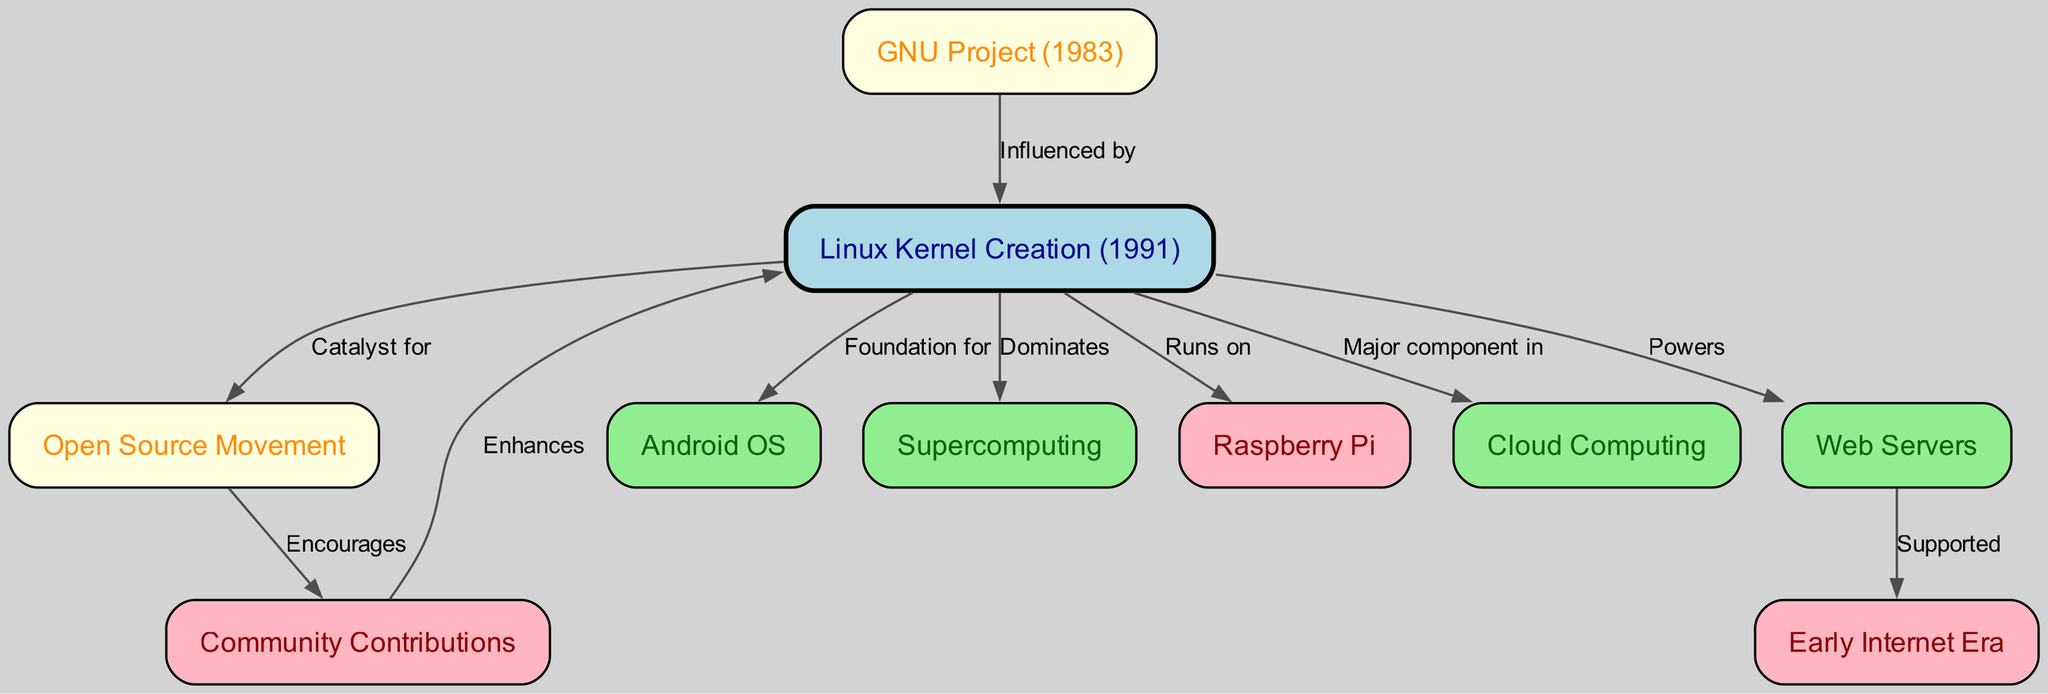What year was the Linux kernel created? The diagram indicates that the Linux kernel was created in 1991. This information can be found directly labeled in the node for "Linux Kernel Creation".
Answer: 1991 What influenced the creation of the Linux kernel? The diagram shows that the "GNU Project" influenced the "Linux Kernel Creation". The relationship is labeled as "Influenced by" in the edge connecting these two nodes.
Answer: GNU Project How many nodes are in the diagram? By counting the nodes listed in the diagram, we see there are 10 unique nodes. This total is determined by examining the nodes section of the data provided.
Answer: 10 What does the Linux kernel dominate in? The diagram states that the Linux kernel "Dominates" supercomputing, indicating its strong presence or leadership in that field, as marked by the directional edge from "Linux Kernel Creation" to "Supercomputing".
Answer: Supercomputing Which technology is the foundation for Android OS? According to the diagram, the "Linux Kernel Creation" serves as the "Foundation for" the "Android OS". This relationship is mapped in the edge pointing from the Linux kernel to the Android OS node.
Answer: Linux Kernel Creation How does the Open Source Movement relate to community contributions? The diagram shows that the "Open Source Movement" "Encourages" "Community Contributions". This connection indicates that the open-source ethos promotes contributions from the community, shown in the relationship between the two nodes.
Answer: Encourages What technology is powered by the Linux kernel? The diagram indicates that "Web Servers" are "Powered" by the "Linux Kernel Creation". This shows the dependency of web server technology on the Linux kernel as highlighted in the diagram.
Answer: Web Servers Which components are major in cloud computing according to the diagram? The diagram states that the Linux kernel is a "Major component in" "Cloud Computing". This indicates the crucial role the Linux OS plays in modern cloud infrastructure.
Answer: Linux Kernel Creation What supported the early internet era? The diagram connects "Web Servers" to the "Early Internet Era" with the label "Supported", highlighting the foundational role of web servers in the development of the early internet.
Answer: Web Servers 